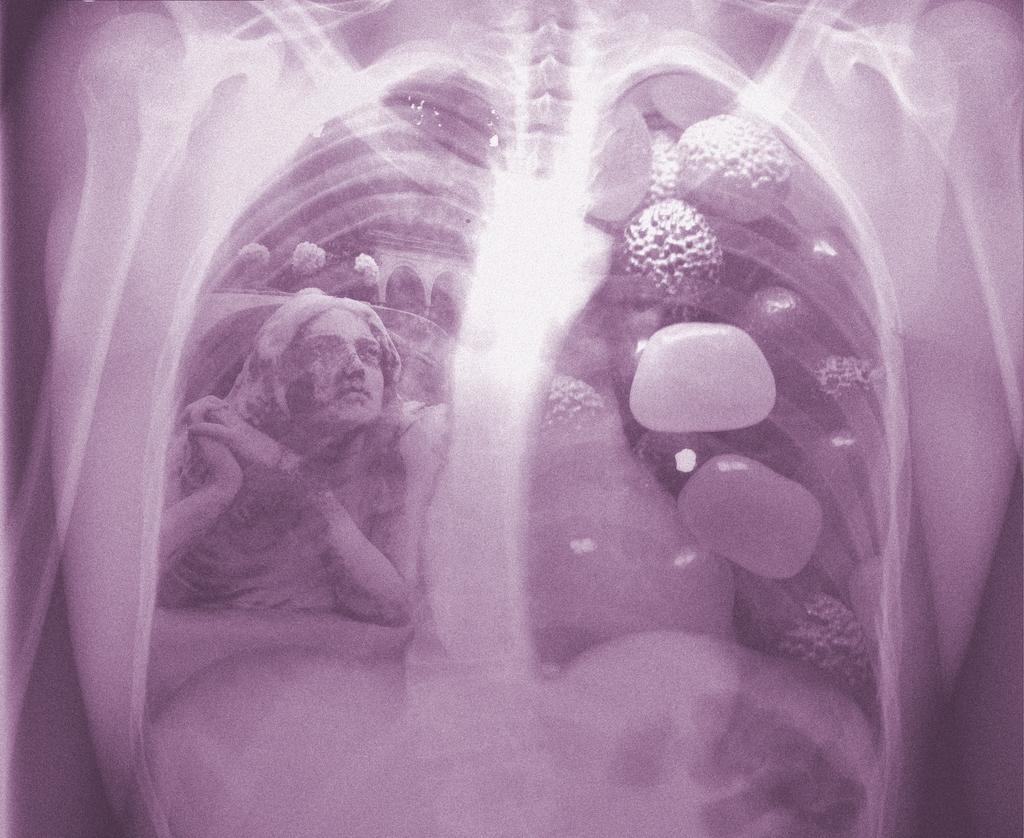What type of image is being displayed? The image is an editing image of an x-ray. Can you identify any human elements in the x-ray? Yes, there is a person in the x-ray. Are there any objects visible in the x-ray? Yes, there are objects in the x-ray. What type of steel is used to create the objects in the x-ray? There is no mention of steel or any specific materials used to create the objects in the x-ray. The image is an edited x-ray, and it does not provide information about the materials used to create the objects. 